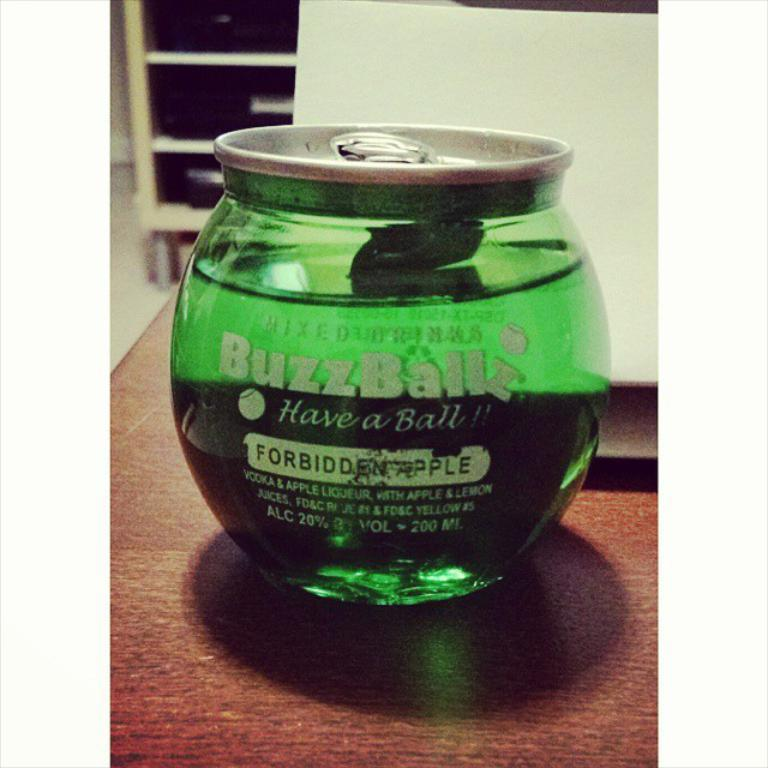<image>
Offer a succinct explanation of the picture presented. A bottle of Buzzball liqueur has 20% alcohol content. 